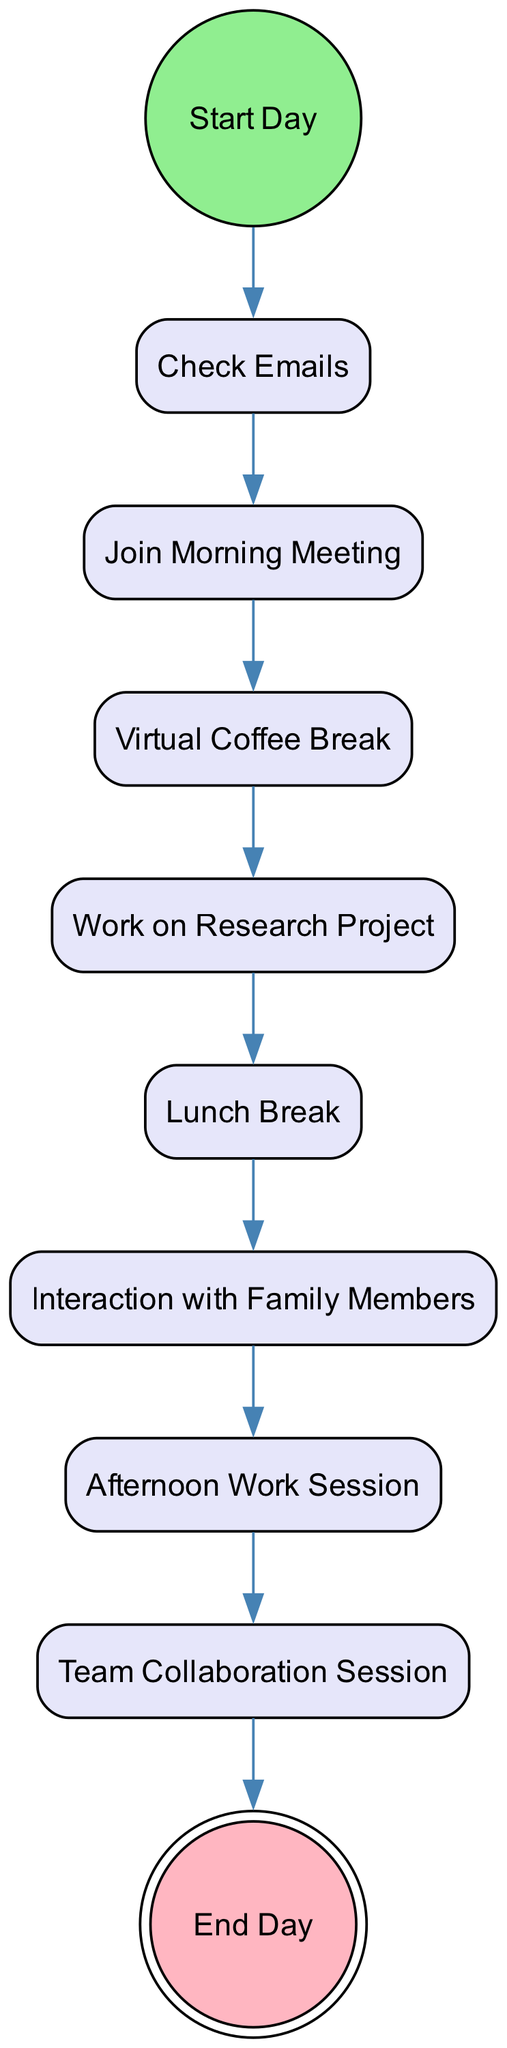What is the first activity in the diagram? The first activity is represented by the "initial" node, which is the starting point of the diagram. According to the data provided, the first activity is "Start Day."
Answer: Start Day How many actions are there in the diagram? To determine the number of actions, we should count the items in the "activities" list where the "type" is "action." In the given data, there are 8 actions: Check Emails, Join Morning Meeting, Virtual Coffee Break, Work on Research Project, Lunch Break, Interaction with Family Members, Afternoon Work Session, and Team Collaboration Session.
Answer: 8 What activity follows the "lunch_break"? To find the next activity, we look for the transition that starts with "lunch_break." According to the transitions, the activity that follows "lunch_break" is "family_interaction."
Answer: Interaction with Family Members What is the last action before the end of the day? The last action before the final "end_day" activity can be found by looking at the transition leading to "end_day." The transition indicates that "team_collaboration" is the last action before ending the day.
Answer: Team Collaboration Session Which activity has a direct transition to "afternoon_work"? To find the activity with a direct transition to "afternoon_work," we check the list of transitions for one that points to "afternoon_work." The transition shows that "family_interaction" leads directly to "afternoon_work."
Answer: Interaction with Family Members Is there a break included in the activities? To answer this question, we must identify if any activity is categorized as a break. The data includes both "Virtual Coffee Break" and "Lunch Break." Therefore, there are breaks present in the activities listed.
Answer: Yes How many different types of nodes are present in the diagram? To determine the different types of nodes, we examine the types present in the "activities" list. There are three types: "initial," "action," and "final." Hence, there are three different types of nodes in the diagram.
Answer: 3 Which action occurs immediately after the "Join Morning Meeting"? We investigate the transition that follows "Join Morning Meeting." According to the transitions, the immediate next action is "Virtual Coffee Break."
Answer: Virtual Coffee Break 